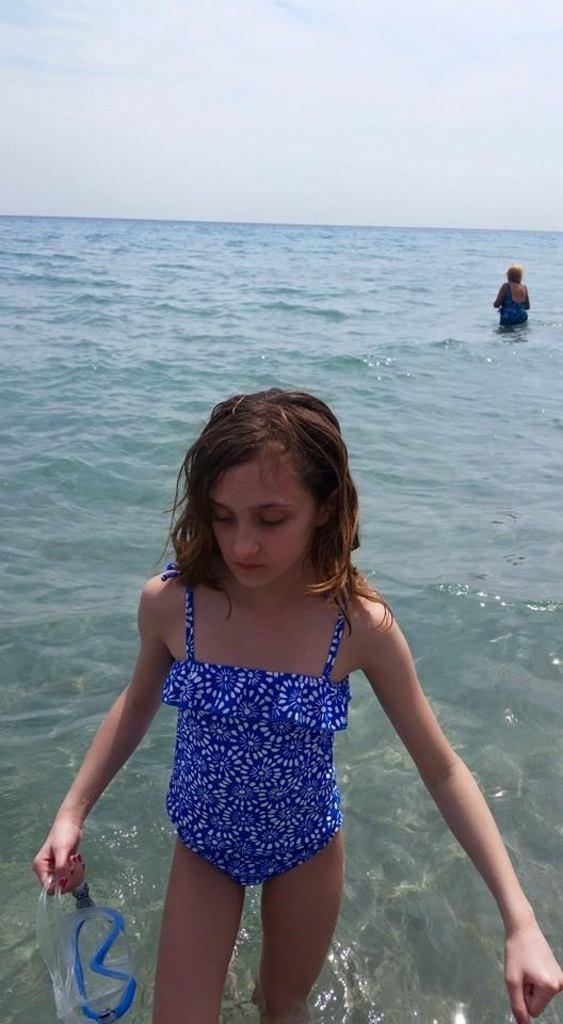How many people are present in the image? There are two people in the image. What can be seen in the background or foreground of the image? There is water visible in the image. What type of quiver can be seen in the image? There is no quiver present in the image. 